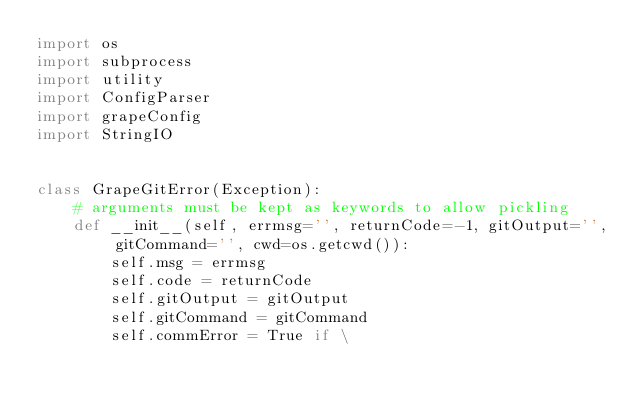Convert code to text. <code><loc_0><loc_0><loc_500><loc_500><_Python_>import os
import subprocess
import utility
import ConfigParser
import grapeConfig
import StringIO


class GrapeGitError(Exception):
    # arguments must be kept as keywords to allow pickling
    def __init__(self, errmsg='', returnCode=-1, gitOutput='', gitCommand='', cwd=os.getcwd()):
        self.msg = errmsg
        self.code = returnCode
        self.gitOutput = gitOutput
        self.gitCommand = gitCommand
        self.commError = True if \</code> 